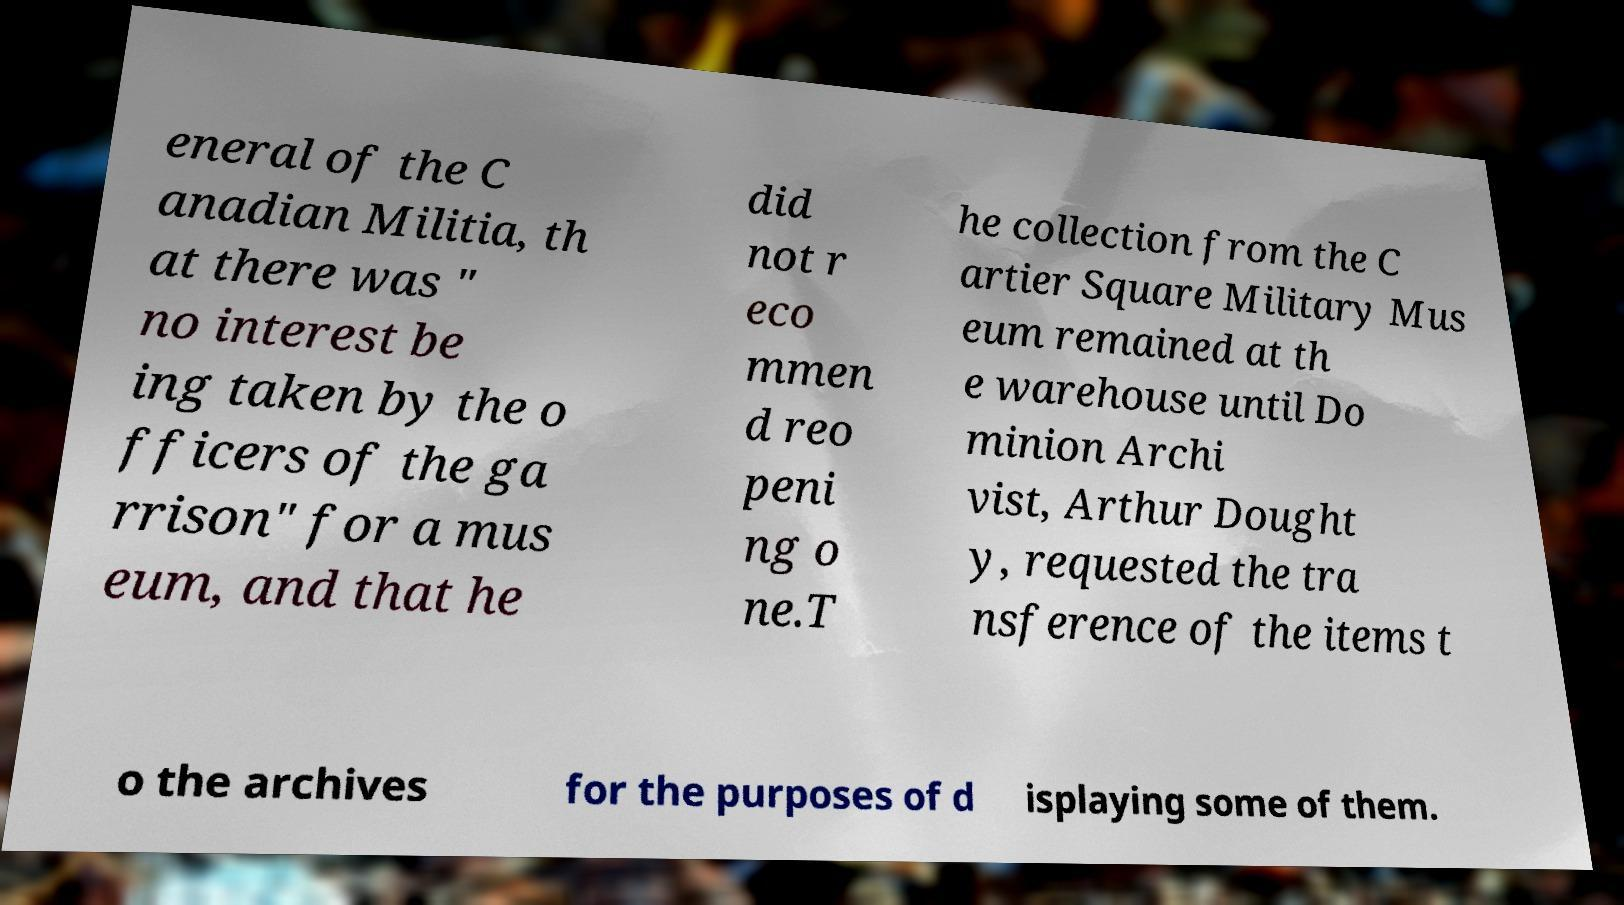There's text embedded in this image that I need extracted. Can you transcribe it verbatim? eneral of the C anadian Militia, th at there was " no interest be ing taken by the o fficers of the ga rrison" for a mus eum, and that he did not r eco mmen d reo peni ng o ne.T he collection from the C artier Square Military Mus eum remained at th e warehouse until Do minion Archi vist, Arthur Dought y, requested the tra nsference of the items t o the archives for the purposes of d isplaying some of them. 